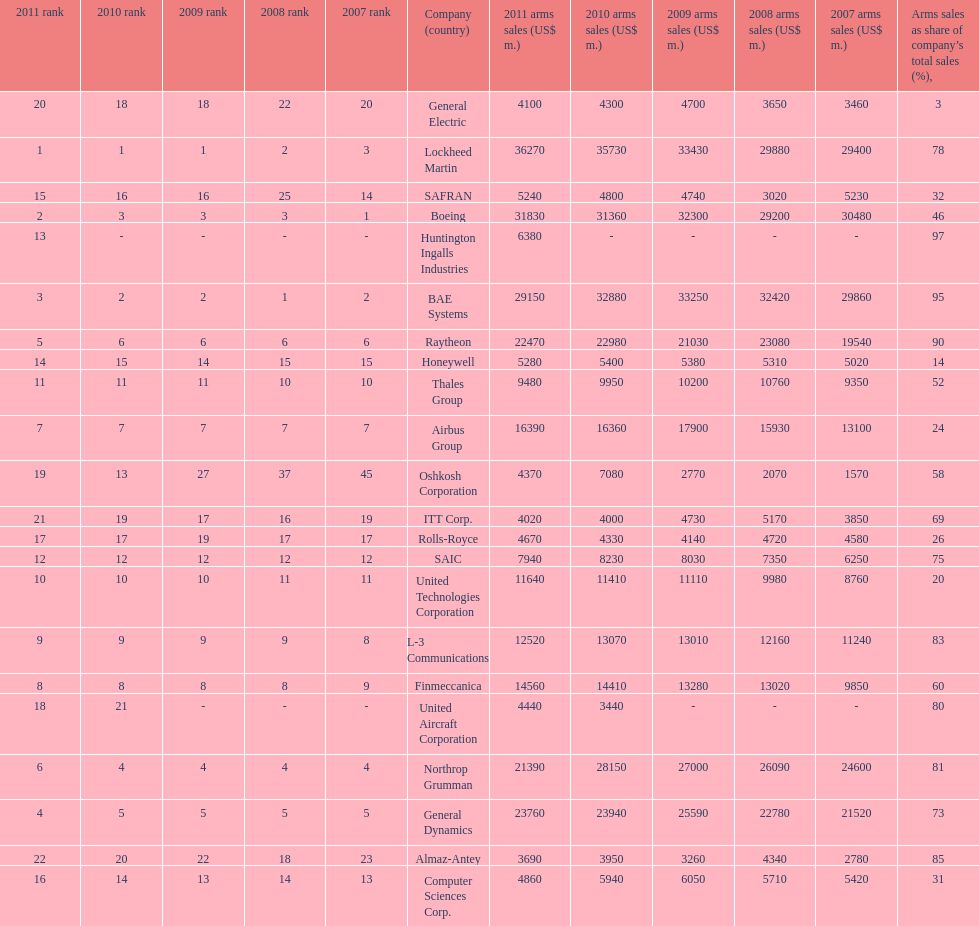Can you give me this table as a dict? {'header': ['2011 rank', '2010 rank', '2009 rank', '2008 rank', '2007 rank', 'Company (country)', '2011 arms sales (US$ m.)', '2010 arms sales (US$ m.)', '2009 arms sales (US$ m.)', '2008 arms sales (US$ m.)', '2007 arms sales (US$ m.)', 'Arms sales as share of company’s total sales (%),'], 'rows': [['20', '18', '18', '22', '20', 'General Electric', '4100', '4300', '4700', '3650', '3460', '3'], ['1', '1', '1', '2', '3', 'Lockheed Martin', '36270', '35730', '33430', '29880', '29400', '78'], ['15', '16', '16', '25', '14', 'SAFRAN', '5240', '4800', '4740', '3020', '5230', '32'], ['2', '3', '3', '3', '1', 'Boeing', '31830', '31360', '32300', '29200', '30480', '46'], ['13', '-', '-', '-', '-', 'Huntington Ingalls Industries', '6380', '-', '-', '-', '-', '97'], ['3', '2', '2', '1', '2', 'BAE Systems', '29150', '32880', '33250', '32420', '29860', '95'], ['5', '6', '6', '6', '6', 'Raytheon', '22470', '22980', '21030', '23080', '19540', '90'], ['14', '15', '14', '15', '15', 'Honeywell', '5280', '5400', '5380', '5310', '5020', '14'], ['11', '11', '11', '10', '10', 'Thales Group', '9480', '9950', '10200', '10760', '9350', '52'], ['7', '7', '7', '7', '7', 'Airbus Group', '16390', '16360', '17900', '15930', '13100', '24'], ['19', '13', '27', '37', '45', 'Oshkosh Corporation', '4370', '7080', '2770', '2070', '1570', '58'], ['21', '19', '17', '16', '19', 'ITT Corp.', '4020', '4000', '4730', '5170', '3850', '69'], ['17', '17', '19', '17', '17', 'Rolls-Royce', '4670', '4330', '4140', '4720', '4580', '26'], ['12', '12', '12', '12', '12', 'SAIC', '7940', '8230', '8030', '7350', '6250', '75'], ['10', '10', '10', '11', '11', 'United Technologies Corporation', '11640', '11410', '11110', '9980', '8760', '20'], ['9', '9', '9', '9', '8', 'L-3 Communications', '12520', '13070', '13010', '12160', '11240', '83'], ['8', '8', '8', '8', '9', 'Finmeccanica', '14560', '14410', '13280', '13020', '9850', '60'], ['18', '21', '-', '-', '-', 'United Aircraft Corporation', '4440', '3440', '-', '-', '-', '80'], ['6', '4', '4', '4', '4', 'Northrop Grumman', '21390', '28150', '27000', '26090', '24600', '81'], ['4', '5', '5', '5', '5', 'General Dynamics', '23760', '23940', '25590', '22780', '21520', '73'], ['22', '20', '22', '18', '23', 'Almaz-Antey', '3690', '3950', '3260', '4340', '2780', '85'], ['16', '14', '13', '14', '13', 'Computer Sciences Corp.', '4860', '5940', '6050', '5710', '5420', '31']]} What country is the first listed country? USA. 